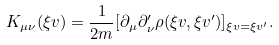Convert formula to latex. <formula><loc_0><loc_0><loc_500><loc_500>K _ { \mu \nu } ( \xi v ) = \frac { 1 } { 2 m } [ \partial _ { \mu } \partial _ { \nu } ^ { \prime } \rho ( \xi v , \xi v ^ { \prime } ) ] _ { \xi v = \xi v ^ { \prime } } .</formula> 